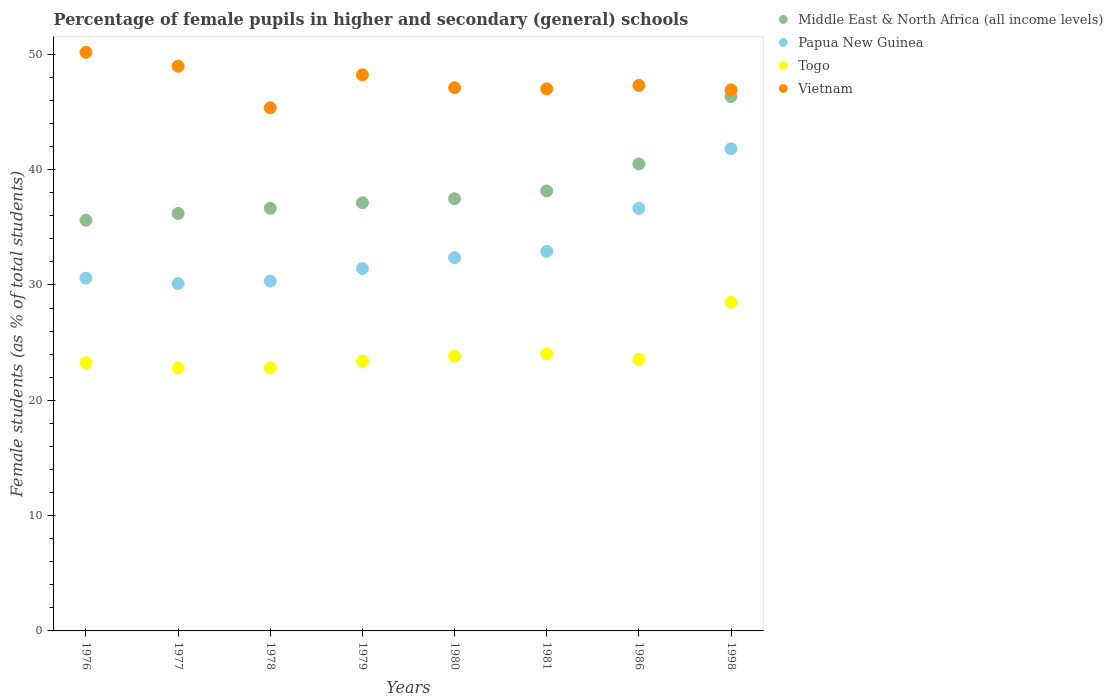How many different coloured dotlines are there?
Ensure brevity in your answer.  4. Is the number of dotlines equal to the number of legend labels?
Your answer should be compact. Yes. What is the percentage of female pupils in higher and secondary schools in Vietnam in 1977?
Offer a terse response. 48.97. Across all years, what is the maximum percentage of female pupils in higher and secondary schools in Vietnam?
Your answer should be compact. 50.17. Across all years, what is the minimum percentage of female pupils in higher and secondary schools in Togo?
Give a very brief answer. 22.81. In which year was the percentage of female pupils in higher and secondary schools in Togo maximum?
Ensure brevity in your answer.  1998. What is the total percentage of female pupils in higher and secondary schools in Papua New Guinea in the graph?
Make the answer very short. 266.19. What is the difference between the percentage of female pupils in higher and secondary schools in Vietnam in 1976 and that in 1980?
Keep it short and to the point. 3.07. What is the difference between the percentage of female pupils in higher and secondary schools in Papua New Guinea in 1998 and the percentage of female pupils in higher and secondary schools in Vietnam in 1986?
Your answer should be very brief. -5.49. What is the average percentage of female pupils in higher and secondary schools in Papua New Guinea per year?
Your response must be concise. 33.27. In the year 1998, what is the difference between the percentage of female pupils in higher and secondary schools in Vietnam and percentage of female pupils in higher and secondary schools in Middle East & North Africa (all income levels)?
Make the answer very short. 0.58. What is the ratio of the percentage of female pupils in higher and secondary schools in Papua New Guinea in 1980 to that in 1986?
Offer a very short reply. 0.88. Is the difference between the percentage of female pupils in higher and secondary schools in Vietnam in 1978 and 1981 greater than the difference between the percentage of female pupils in higher and secondary schools in Middle East & North Africa (all income levels) in 1978 and 1981?
Provide a succinct answer. No. What is the difference between the highest and the second highest percentage of female pupils in higher and secondary schools in Middle East & North Africa (all income levels)?
Provide a succinct answer. 5.84. What is the difference between the highest and the lowest percentage of female pupils in higher and secondary schools in Togo?
Keep it short and to the point. 5.7. Is the sum of the percentage of female pupils in higher and secondary schools in Papua New Guinea in 1976 and 1980 greater than the maximum percentage of female pupils in higher and secondary schools in Middle East & North Africa (all income levels) across all years?
Provide a succinct answer. Yes. Is it the case that in every year, the sum of the percentage of female pupils in higher and secondary schools in Middle East & North Africa (all income levels) and percentage of female pupils in higher and secondary schools in Togo  is greater than the sum of percentage of female pupils in higher and secondary schools in Papua New Guinea and percentage of female pupils in higher and secondary schools in Vietnam?
Your response must be concise. No. Is the percentage of female pupils in higher and secondary schools in Papua New Guinea strictly greater than the percentage of female pupils in higher and secondary schools in Togo over the years?
Your answer should be very brief. Yes. Are the values on the major ticks of Y-axis written in scientific E-notation?
Ensure brevity in your answer.  No. Does the graph contain any zero values?
Your answer should be compact. No. How many legend labels are there?
Provide a short and direct response. 4. How are the legend labels stacked?
Provide a succinct answer. Vertical. What is the title of the graph?
Offer a very short reply. Percentage of female pupils in higher and secondary (general) schools. What is the label or title of the X-axis?
Provide a succinct answer. Years. What is the label or title of the Y-axis?
Offer a very short reply. Female students (as % of total students). What is the Female students (as % of total students) in Middle East & North Africa (all income levels) in 1976?
Your answer should be very brief. 35.61. What is the Female students (as % of total students) in Papua New Guinea in 1976?
Your answer should be compact. 30.59. What is the Female students (as % of total students) in Togo in 1976?
Make the answer very short. 23.26. What is the Female students (as % of total students) of Vietnam in 1976?
Provide a short and direct response. 50.17. What is the Female students (as % of total students) of Middle East & North Africa (all income levels) in 1977?
Your answer should be very brief. 36.2. What is the Female students (as % of total students) of Papua New Guinea in 1977?
Provide a short and direct response. 30.11. What is the Female students (as % of total students) of Togo in 1977?
Keep it short and to the point. 22.81. What is the Female students (as % of total students) of Vietnam in 1977?
Offer a terse response. 48.97. What is the Female students (as % of total students) of Middle East & North Africa (all income levels) in 1978?
Offer a terse response. 36.65. What is the Female students (as % of total students) of Papua New Guinea in 1978?
Your response must be concise. 30.33. What is the Female students (as % of total students) in Togo in 1978?
Ensure brevity in your answer.  22.81. What is the Female students (as % of total students) of Vietnam in 1978?
Make the answer very short. 45.36. What is the Female students (as % of total students) in Middle East & North Africa (all income levels) in 1979?
Your response must be concise. 37.13. What is the Female students (as % of total students) of Papua New Guinea in 1979?
Ensure brevity in your answer.  31.42. What is the Female students (as % of total students) in Togo in 1979?
Ensure brevity in your answer.  23.4. What is the Female students (as % of total students) of Vietnam in 1979?
Provide a short and direct response. 48.22. What is the Female students (as % of total students) in Middle East & North Africa (all income levels) in 1980?
Ensure brevity in your answer.  37.48. What is the Female students (as % of total students) in Papua New Guinea in 1980?
Offer a very short reply. 32.37. What is the Female students (as % of total students) in Togo in 1980?
Offer a very short reply. 23.82. What is the Female students (as % of total students) of Vietnam in 1980?
Your response must be concise. 47.1. What is the Female students (as % of total students) of Middle East & North Africa (all income levels) in 1981?
Your answer should be very brief. 38.15. What is the Female students (as % of total students) in Papua New Guinea in 1981?
Offer a terse response. 32.91. What is the Female students (as % of total students) of Togo in 1981?
Your answer should be compact. 24.03. What is the Female students (as % of total students) in Vietnam in 1981?
Offer a very short reply. 47. What is the Female students (as % of total students) in Middle East & North Africa (all income levels) in 1986?
Ensure brevity in your answer.  40.49. What is the Female students (as % of total students) in Papua New Guinea in 1986?
Your answer should be very brief. 36.64. What is the Female students (as % of total students) of Togo in 1986?
Your response must be concise. 23.55. What is the Female students (as % of total students) of Vietnam in 1986?
Keep it short and to the point. 47.3. What is the Female students (as % of total students) of Middle East & North Africa (all income levels) in 1998?
Offer a terse response. 46.34. What is the Female students (as % of total students) of Papua New Guinea in 1998?
Make the answer very short. 41.81. What is the Female students (as % of total students) of Togo in 1998?
Offer a terse response. 28.51. What is the Female students (as % of total students) in Vietnam in 1998?
Your answer should be compact. 46.92. Across all years, what is the maximum Female students (as % of total students) in Middle East & North Africa (all income levels)?
Provide a succinct answer. 46.34. Across all years, what is the maximum Female students (as % of total students) of Papua New Guinea?
Your response must be concise. 41.81. Across all years, what is the maximum Female students (as % of total students) of Togo?
Make the answer very short. 28.51. Across all years, what is the maximum Female students (as % of total students) in Vietnam?
Offer a very short reply. 50.17. Across all years, what is the minimum Female students (as % of total students) of Middle East & North Africa (all income levels)?
Your response must be concise. 35.61. Across all years, what is the minimum Female students (as % of total students) in Papua New Guinea?
Keep it short and to the point. 30.11. Across all years, what is the minimum Female students (as % of total students) of Togo?
Your response must be concise. 22.81. Across all years, what is the minimum Female students (as % of total students) in Vietnam?
Your answer should be compact. 45.36. What is the total Female students (as % of total students) of Middle East & North Africa (all income levels) in the graph?
Ensure brevity in your answer.  308.04. What is the total Female students (as % of total students) in Papua New Guinea in the graph?
Your response must be concise. 266.19. What is the total Female students (as % of total students) in Togo in the graph?
Keep it short and to the point. 192.18. What is the total Female students (as % of total students) in Vietnam in the graph?
Make the answer very short. 381.05. What is the difference between the Female students (as % of total students) in Middle East & North Africa (all income levels) in 1976 and that in 1977?
Ensure brevity in your answer.  -0.59. What is the difference between the Female students (as % of total students) in Papua New Guinea in 1976 and that in 1977?
Keep it short and to the point. 0.47. What is the difference between the Female students (as % of total students) of Togo in 1976 and that in 1977?
Keep it short and to the point. 0.45. What is the difference between the Female students (as % of total students) of Vietnam in 1976 and that in 1977?
Make the answer very short. 1.2. What is the difference between the Female students (as % of total students) in Middle East & North Africa (all income levels) in 1976 and that in 1978?
Offer a terse response. -1.03. What is the difference between the Female students (as % of total students) of Papua New Guinea in 1976 and that in 1978?
Provide a succinct answer. 0.25. What is the difference between the Female students (as % of total students) of Togo in 1976 and that in 1978?
Provide a succinct answer. 0.45. What is the difference between the Female students (as % of total students) of Vietnam in 1976 and that in 1978?
Offer a terse response. 4.81. What is the difference between the Female students (as % of total students) in Middle East & North Africa (all income levels) in 1976 and that in 1979?
Make the answer very short. -1.52. What is the difference between the Female students (as % of total students) of Papua New Guinea in 1976 and that in 1979?
Make the answer very short. -0.84. What is the difference between the Female students (as % of total students) in Togo in 1976 and that in 1979?
Your answer should be very brief. -0.14. What is the difference between the Female students (as % of total students) in Vietnam in 1976 and that in 1979?
Your answer should be very brief. 1.95. What is the difference between the Female students (as % of total students) of Middle East & North Africa (all income levels) in 1976 and that in 1980?
Provide a succinct answer. -1.87. What is the difference between the Female students (as % of total students) of Papua New Guinea in 1976 and that in 1980?
Ensure brevity in your answer.  -1.78. What is the difference between the Female students (as % of total students) of Togo in 1976 and that in 1980?
Provide a short and direct response. -0.56. What is the difference between the Female students (as % of total students) in Vietnam in 1976 and that in 1980?
Provide a succinct answer. 3.07. What is the difference between the Female students (as % of total students) of Middle East & North Africa (all income levels) in 1976 and that in 1981?
Give a very brief answer. -2.54. What is the difference between the Female students (as % of total students) of Papua New Guinea in 1976 and that in 1981?
Your answer should be very brief. -2.32. What is the difference between the Female students (as % of total students) of Togo in 1976 and that in 1981?
Provide a succinct answer. -0.77. What is the difference between the Female students (as % of total students) of Vietnam in 1976 and that in 1981?
Your answer should be compact. 3.17. What is the difference between the Female students (as % of total students) of Middle East & North Africa (all income levels) in 1976 and that in 1986?
Offer a very short reply. -4.88. What is the difference between the Female students (as % of total students) in Papua New Guinea in 1976 and that in 1986?
Your response must be concise. -6.06. What is the difference between the Female students (as % of total students) of Togo in 1976 and that in 1986?
Make the answer very short. -0.29. What is the difference between the Female students (as % of total students) in Vietnam in 1976 and that in 1986?
Your answer should be very brief. 2.87. What is the difference between the Female students (as % of total students) in Middle East & North Africa (all income levels) in 1976 and that in 1998?
Your answer should be compact. -10.73. What is the difference between the Female students (as % of total students) of Papua New Guinea in 1976 and that in 1998?
Offer a very short reply. -11.23. What is the difference between the Female students (as % of total students) in Togo in 1976 and that in 1998?
Give a very brief answer. -5.25. What is the difference between the Female students (as % of total students) in Middle East & North Africa (all income levels) in 1977 and that in 1978?
Keep it short and to the point. -0.45. What is the difference between the Female students (as % of total students) of Papua New Guinea in 1977 and that in 1978?
Your answer should be compact. -0.22. What is the difference between the Female students (as % of total students) in Togo in 1977 and that in 1978?
Offer a very short reply. -0. What is the difference between the Female students (as % of total students) of Vietnam in 1977 and that in 1978?
Keep it short and to the point. 3.6. What is the difference between the Female students (as % of total students) in Middle East & North Africa (all income levels) in 1977 and that in 1979?
Provide a short and direct response. -0.93. What is the difference between the Female students (as % of total students) in Papua New Guinea in 1977 and that in 1979?
Keep it short and to the point. -1.31. What is the difference between the Female students (as % of total students) of Togo in 1977 and that in 1979?
Provide a succinct answer. -0.59. What is the difference between the Female students (as % of total students) of Vietnam in 1977 and that in 1979?
Your response must be concise. 0.75. What is the difference between the Female students (as % of total students) of Middle East & North Africa (all income levels) in 1977 and that in 1980?
Your answer should be compact. -1.28. What is the difference between the Female students (as % of total students) of Papua New Guinea in 1977 and that in 1980?
Offer a very short reply. -2.25. What is the difference between the Female students (as % of total students) in Togo in 1977 and that in 1980?
Provide a succinct answer. -1.01. What is the difference between the Female students (as % of total students) in Vietnam in 1977 and that in 1980?
Ensure brevity in your answer.  1.86. What is the difference between the Female students (as % of total students) in Middle East & North Africa (all income levels) in 1977 and that in 1981?
Make the answer very short. -1.96. What is the difference between the Female students (as % of total students) in Papua New Guinea in 1977 and that in 1981?
Give a very brief answer. -2.79. What is the difference between the Female students (as % of total students) of Togo in 1977 and that in 1981?
Make the answer very short. -1.22. What is the difference between the Female students (as % of total students) in Vietnam in 1977 and that in 1981?
Make the answer very short. 1.97. What is the difference between the Female students (as % of total students) in Middle East & North Africa (all income levels) in 1977 and that in 1986?
Keep it short and to the point. -4.3. What is the difference between the Female students (as % of total students) of Papua New Guinea in 1977 and that in 1986?
Make the answer very short. -6.53. What is the difference between the Female students (as % of total students) in Togo in 1977 and that in 1986?
Ensure brevity in your answer.  -0.74. What is the difference between the Female students (as % of total students) in Vietnam in 1977 and that in 1986?
Your response must be concise. 1.66. What is the difference between the Female students (as % of total students) in Middle East & North Africa (all income levels) in 1977 and that in 1998?
Your answer should be compact. -10.14. What is the difference between the Female students (as % of total students) of Papua New Guinea in 1977 and that in 1998?
Provide a short and direct response. -11.7. What is the difference between the Female students (as % of total students) of Togo in 1977 and that in 1998?
Give a very brief answer. -5.7. What is the difference between the Female students (as % of total students) in Vietnam in 1977 and that in 1998?
Provide a succinct answer. 2.05. What is the difference between the Female students (as % of total students) in Middle East & North Africa (all income levels) in 1978 and that in 1979?
Make the answer very short. -0.48. What is the difference between the Female students (as % of total students) in Papua New Guinea in 1978 and that in 1979?
Give a very brief answer. -1.09. What is the difference between the Female students (as % of total students) of Togo in 1978 and that in 1979?
Provide a succinct answer. -0.59. What is the difference between the Female students (as % of total students) in Vietnam in 1978 and that in 1979?
Your answer should be compact. -2.86. What is the difference between the Female students (as % of total students) of Middle East & North Africa (all income levels) in 1978 and that in 1980?
Provide a succinct answer. -0.83. What is the difference between the Female students (as % of total students) in Papua New Guinea in 1978 and that in 1980?
Your answer should be very brief. -2.03. What is the difference between the Female students (as % of total students) of Togo in 1978 and that in 1980?
Your answer should be compact. -1.01. What is the difference between the Female students (as % of total students) in Vietnam in 1978 and that in 1980?
Provide a succinct answer. -1.74. What is the difference between the Female students (as % of total students) of Middle East & North Africa (all income levels) in 1978 and that in 1981?
Offer a terse response. -1.51. What is the difference between the Female students (as % of total students) in Papua New Guinea in 1978 and that in 1981?
Give a very brief answer. -2.57. What is the difference between the Female students (as % of total students) in Togo in 1978 and that in 1981?
Your response must be concise. -1.22. What is the difference between the Female students (as % of total students) of Vietnam in 1978 and that in 1981?
Keep it short and to the point. -1.64. What is the difference between the Female students (as % of total students) of Middle East & North Africa (all income levels) in 1978 and that in 1986?
Ensure brevity in your answer.  -3.85. What is the difference between the Female students (as % of total students) of Papua New Guinea in 1978 and that in 1986?
Your answer should be very brief. -6.31. What is the difference between the Female students (as % of total students) in Togo in 1978 and that in 1986?
Offer a very short reply. -0.73. What is the difference between the Female students (as % of total students) in Vietnam in 1978 and that in 1986?
Offer a terse response. -1.94. What is the difference between the Female students (as % of total students) in Middle East & North Africa (all income levels) in 1978 and that in 1998?
Offer a very short reply. -9.69. What is the difference between the Female students (as % of total students) in Papua New Guinea in 1978 and that in 1998?
Provide a succinct answer. -11.48. What is the difference between the Female students (as % of total students) of Togo in 1978 and that in 1998?
Keep it short and to the point. -5.69. What is the difference between the Female students (as % of total students) in Vietnam in 1978 and that in 1998?
Offer a terse response. -1.56. What is the difference between the Female students (as % of total students) of Middle East & North Africa (all income levels) in 1979 and that in 1980?
Make the answer very short. -0.35. What is the difference between the Female students (as % of total students) of Papua New Guinea in 1979 and that in 1980?
Your response must be concise. -0.95. What is the difference between the Female students (as % of total students) in Togo in 1979 and that in 1980?
Ensure brevity in your answer.  -0.42. What is the difference between the Female students (as % of total students) in Vietnam in 1979 and that in 1980?
Provide a short and direct response. 1.12. What is the difference between the Female students (as % of total students) in Middle East & North Africa (all income levels) in 1979 and that in 1981?
Your answer should be very brief. -1.02. What is the difference between the Female students (as % of total students) of Papua New Guinea in 1979 and that in 1981?
Offer a terse response. -1.49. What is the difference between the Female students (as % of total students) of Togo in 1979 and that in 1981?
Keep it short and to the point. -0.63. What is the difference between the Female students (as % of total students) in Vietnam in 1979 and that in 1981?
Keep it short and to the point. 1.22. What is the difference between the Female students (as % of total students) in Middle East & North Africa (all income levels) in 1979 and that in 1986?
Ensure brevity in your answer.  -3.37. What is the difference between the Female students (as % of total students) in Papua New Guinea in 1979 and that in 1986?
Offer a very short reply. -5.22. What is the difference between the Female students (as % of total students) in Togo in 1979 and that in 1986?
Make the answer very short. -0.14. What is the difference between the Female students (as % of total students) in Vietnam in 1979 and that in 1986?
Offer a very short reply. 0.92. What is the difference between the Female students (as % of total students) of Middle East & North Africa (all income levels) in 1979 and that in 1998?
Make the answer very short. -9.21. What is the difference between the Female students (as % of total students) of Papua New Guinea in 1979 and that in 1998?
Your answer should be compact. -10.39. What is the difference between the Female students (as % of total students) of Togo in 1979 and that in 1998?
Offer a very short reply. -5.11. What is the difference between the Female students (as % of total students) in Vietnam in 1979 and that in 1998?
Your response must be concise. 1.3. What is the difference between the Female students (as % of total students) in Middle East & North Africa (all income levels) in 1980 and that in 1981?
Keep it short and to the point. -0.68. What is the difference between the Female students (as % of total students) of Papua New Guinea in 1980 and that in 1981?
Your response must be concise. -0.54. What is the difference between the Female students (as % of total students) of Togo in 1980 and that in 1981?
Your response must be concise. -0.21. What is the difference between the Female students (as % of total students) in Vietnam in 1980 and that in 1981?
Make the answer very short. 0.1. What is the difference between the Female students (as % of total students) of Middle East & North Africa (all income levels) in 1980 and that in 1986?
Keep it short and to the point. -3.02. What is the difference between the Female students (as % of total students) in Papua New Guinea in 1980 and that in 1986?
Give a very brief answer. -4.28. What is the difference between the Female students (as % of total students) in Togo in 1980 and that in 1986?
Make the answer very short. 0.27. What is the difference between the Female students (as % of total students) of Vietnam in 1980 and that in 1986?
Provide a succinct answer. -0.2. What is the difference between the Female students (as % of total students) in Middle East & North Africa (all income levels) in 1980 and that in 1998?
Provide a succinct answer. -8.86. What is the difference between the Female students (as % of total students) in Papua New Guinea in 1980 and that in 1998?
Offer a very short reply. -9.45. What is the difference between the Female students (as % of total students) in Togo in 1980 and that in 1998?
Your answer should be compact. -4.69. What is the difference between the Female students (as % of total students) of Vietnam in 1980 and that in 1998?
Provide a short and direct response. 0.18. What is the difference between the Female students (as % of total students) of Middle East & North Africa (all income levels) in 1981 and that in 1986?
Give a very brief answer. -2.34. What is the difference between the Female students (as % of total students) in Papua New Guinea in 1981 and that in 1986?
Provide a succinct answer. -3.73. What is the difference between the Female students (as % of total students) in Togo in 1981 and that in 1986?
Offer a terse response. 0.48. What is the difference between the Female students (as % of total students) of Vietnam in 1981 and that in 1986?
Provide a succinct answer. -0.3. What is the difference between the Female students (as % of total students) of Middle East & North Africa (all income levels) in 1981 and that in 1998?
Keep it short and to the point. -8.18. What is the difference between the Female students (as % of total students) of Papua New Guinea in 1981 and that in 1998?
Offer a very short reply. -8.91. What is the difference between the Female students (as % of total students) in Togo in 1981 and that in 1998?
Provide a succinct answer. -4.48. What is the difference between the Female students (as % of total students) in Vietnam in 1981 and that in 1998?
Give a very brief answer. 0.08. What is the difference between the Female students (as % of total students) of Middle East & North Africa (all income levels) in 1986 and that in 1998?
Your answer should be compact. -5.84. What is the difference between the Female students (as % of total students) in Papua New Guinea in 1986 and that in 1998?
Offer a terse response. -5.17. What is the difference between the Female students (as % of total students) in Togo in 1986 and that in 1998?
Your response must be concise. -4.96. What is the difference between the Female students (as % of total students) of Vietnam in 1986 and that in 1998?
Provide a short and direct response. 0.38. What is the difference between the Female students (as % of total students) in Middle East & North Africa (all income levels) in 1976 and the Female students (as % of total students) in Papua New Guinea in 1977?
Keep it short and to the point. 5.5. What is the difference between the Female students (as % of total students) in Middle East & North Africa (all income levels) in 1976 and the Female students (as % of total students) in Togo in 1977?
Your answer should be compact. 12.8. What is the difference between the Female students (as % of total students) of Middle East & North Africa (all income levels) in 1976 and the Female students (as % of total students) of Vietnam in 1977?
Your answer should be compact. -13.36. What is the difference between the Female students (as % of total students) of Papua New Guinea in 1976 and the Female students (as % of total students) of Togo in 1977?
Keep it short and to the point. 7.78. What is the difference between the Female students (as % of total students) in Papua New Guinea in 1976 and the Female students (as % of total students) in Vietnam in 1977?
Offer a terse response. -18.38. What is the difference between the Female students (as % of total students) in Togo in 1976 and the Female students (as % of total students) in Vietnam in 1977?
Provide a succinct answer. -25.71. What is the difference between the Female students (as % of total students) of Middle East & North Africa (all income levels) in 1976 and the Female students (as % of total students) of Papua New Guinea in 1978?
Your answer should be compact. 5.28. What is the difference between the Female students (as % of total students) of Middle East & North Africa (all income levels) in 1976 and the Female students (as % of total students) of Togo in 1978?
Ensure brevity in your answer.  12.8. What is the difference between the Female students (as % of total students) of Middle East & North Africa (all income levels) in 1976 and the Female students (as % of total students) of Vietnam in 1978?
Provide a short and direct response. -9.75. What is the difference between the Female students (as % of total students) of Papua New Guinea in 1976 and the Female students (as % of total students) of Togo in 1978?
Your response must be concise. 7.77. What is the difference between the Female students (as % of total students) of Papua New Guinea in 1976 and the Female students (as % of total students) of Vietnam in 1978?
Your answer should be compact. -14.78. What is the difference between the Female students (as % of total students) of Togo in 1976 and the Female students (as % of total students) of Vietnam in 1978?
Keep it short and to the point. -22.11. What is the difference between the Female students (as % of total students) in Middle East & North Africa (all income levels) in 1976 and the Female students (as % of total students) in Papua New Guinea in 1979?
Give a very brief answer. 4.19. What is the difference between the Female students (as % of total students) in Middle East & North Africa (all income levels) in 1976 and the Female students (as % of total students) in Togo in 1979?
Offer a terse response. 12.21. What is the difference between the Female students (as % of total students) of Middle East & North Africa (all income levels) in 1976 and the Female students (as % of total students) of Vietnam in 1979?
Provide a succinct answer. -12.61. What is the difference between the Female students (as % of total students) of Papua New Guinea in 1976 and the Female students (as % of total students) of Togo in 1979?
Your response must be concise. 7.19. What is the difference between the Female students (as % of total students) in Papua New Guinea in 1976 and the Female students (as % of total students) in Vietnam in 1979?
Offer a terse response. -17.64. What is the difference between the Female students (as % of total students) in Togo in 1976 and the Female students (as % of total students) in Vietnam in 1979?
Keep it short and to the point. -24.96. What is the difference between the Female students (as % of total students) in Middle East & North Africa (all income levels) in 1976 and the Female students (as % of total students) in Papua New Guinea in 1980?
Offer a terse response. 3.24. What is the difference between the Female students (as % of total students) of Middle East & North Africa (all income levels) in 1976 and the Female students (as % of total students) of Togo in 1980?
Ensure brevity in your answer.  11.79. What is the difference between the Female students (as % of total students) of Middle East & North Africa (all income levels) in 1976 and the Female students (as % of total students) of Vietnam in 1980?
Keep it short and to the point. -11.49. What is the difference between the Female students (as % of total students) of Papua New Guinea in 1976 and the Female students (as % of total students) of Togo in 1980?
Your response must be concise. 6.77. What is the difference between the Female students (as % of total students) of Papua New Guinea in 1976 and the Female students (as % of total students) of Vietnam in 1980?
Ensure brevity in your answer.  -16.52. What is the difference between the Female students (as % of total students) of Togo in 1976 and the Female students (as % of total students) of Vietnam in 1980?
Provide a succinct answer. -23.84. What is the difference between the Female students (as % of total students) of Middle East & North Africa (all income levels) in 1976 and the Female students (as % of total students) of Papua New Guinea in 1981?
Offer a terse response. 2.7. What is the difference between the Female students (as % of total students) of Middle East & North Africa (all income levels) in 1976 and the Female students (as % of total students) of Togo in 1981?
Keep it short and to the point. 11.58. What is the difference between the Female students (as % of total students) of Middle East & North Africa (all income levels) in 1976 and the Female students (as % of total students) of Vietnam in 1981?
Provide a succinct answer. -11.39. What is the difference between the Female students (as % of total students) of Papua New Guinea in 1976 and the Female students (as % of total students) of Togo in 1981?
Provide a short and direct response. 6.56. What is the difference between the Female students (as % of total students) in Papua New Guinea in 1976 and the Female students (as % of total students) in Vietnam in 1981?
Your answer should be very brief. -16.42. What is the difference between the Female students (as % of total students) of Togo in 1976 and the Female students (as % of total students) of Vietnam in 1981?
Offer a terse response. -23.74. What is the difference between the Female students (as % of total students) of Middle East & North Africa (all income levels) in 1976 and the Female students (as % of total students) of Papua New Guinea in 1986?
Provide a succinct answer. -1.03. What is the difference between the Female students (as % of total students) of Middle East & North Africa (all income levels) in 1976 and the Female students (as % of total students) of Togo in 1986?
Your answer should be compact. 12.06. What is the difference between the Female students (as % of total students) in Middle East & North Africa (all income levels) in 1976 and the Female students (as % of total students) in Vietnam in 1986?
Make the answer very short. -11.69. What is the difference between the Female students (as % of total students) in Papua New Guinea in 1976 and the Female students (as % of total students) in Togo in 1986?
Make the answer very short. 7.04. What is the difference between the Female students (as % of total students) in Papua New Guinea in 1976 and the Female students (as % of total students) in Vietnam in 1986?
Your response must be concise. -16.72. What is the difference between the Female students (as % of total students) in Togo in 1976 and the Female students (as % of total students) in Vietnam in 1986?
Keep it short and to the point. -24.04. What is the difference between the Female students (as % of total students) in Middle East & North Africa (all income levels) in 1976 and the Female students (as % of total students) in Papua New Guinea in 1998?
Your response must be concise. -6.2. What is the difference between the Female students (as % of total students) in Middle East & North Africa (all income levels) in 1976 and the Female students (as % of total students) in Togo in 1998?
Your response must be concise. 7.1. What is the difference between the Female students (as % of total students) in Middle East & North Africa (all income levels) in 1976 and the Female students (as % of total students) in Vietnam in 1998?
Provide a succinct answer. -11.31. What is the difference between the Female students (as % of total students) of Papua New Guinea in 1976 and the Female students (as % of total students) of Togo in 1998?
Provide a succinct answer. 2.08. What is the difference between the Female students (as % of total students) in Papua New Guinea in 1976 and the Female students (as % of total students) in Vietnam in 1998?
Offer a terse response. -16.33. What is the difference between the Female students (as % of total students) in Togo in 1976 and the Female students (as % of total students) in Vietnam in 1998?
Keep it short and to the point. -23.66. What is the difference between the Female students (as % of total students) in Middle East & North Africa (all income levels) in 1977 and the Female students (as % of total students) in Papua New Guinea in 1978?
Your answer should be compact. 5.86. What is the difference between the Female students (as % of total students) in Middle East & North Africa (all income levels) in 1977 and the Female students (as % of total students) in Togo in 1978?
Provide a succinct answer. 13.38. What is the difference between the Female students (as % of total students) of Middle East & North Africa (all income levels) in 1977 and the Female students (as % of total students) of Vietnam in 1978?
Provide a succinct answer. -9.17. What is the difference between the Female students (as % of total students) of Papua New Guinea in 1977 and the Female students (as % of total students) of Togo in 1978?
Ensure brevity in your answer.  7.3. What is the difference between the Female students (as % of total students) of Papua New Guinea in 1977 and the Female students (as % of total students) of Vietnam in 1978?
Provide a succinct answer. -15.25. What is the difference between the Female students (as % of total students) of Togo in 1977 and the Female students (as % of total students) of Vietnam in 1978?
Your response must be concise. -22.55. What is the difference between the Female students (as % of total students) in Middle East & North Africa (all income levels) in 1977 and the Female students (as % of total students) in Papua New Guinea in 1979?
Keep it short and to the point. 4.77. What is the difference between the Female students (as % of total students) of Middle East & North Africa (all income levels) in 1977 and the Female students (as % of total students) of Togo in 1979?
Offer a terse response. 12.8. What is the difference between the Female students (as % of total students) in Middle East & North Africa (all income levels) in 1977 and the Female students (as % of total students) in Vietnam in 1979?
Make the answer very short. -12.03. What is the difference between the Female students (as % of total students) of Papua New Guinea in 1977 and the Female students (as % of total students) of Togo in 1979?
Your answer should be compact. 6.71. What is the difference between the Female students (as % of total students) in Papua New Guinea in 1977 and the Female students (as % of total students) in Vietnam in 1979?
Your answer should be compact. -18.11. What is the difference between the Female students (as % of total students) of Togo in 1977 and the Female students (as % of total students) of Vietnam in 1979?
Provide a succinct answer. -25.41. What is the difference between the Female students (as % of total students) of Middle East & North Africa (all income levels) in 1977 and the Female students (as % of total students) of Papua New Guinea in 1980?
Your answer should be very brief. 3.83. What is the difference between the Female students (as % of total students) of Middle East & North Africa (all income levels) in 1977 and the Female students (as % of total students) of Togo in 1980?
Your answer should be compact. 12.38. What is the difference between the Female students (as % of total students) in Middle East & North Africa (all income levels) in 1977 and the Female students (as % of total students) in Vietnam in 1980?
Make the answer very short. -10.91. What is the difference between the Female students (as % of total students) of Papua New Guinea in 1977 and the Female students (as % of total students) of Togo in 1980?
Make the answer very short. 6.3. What is the difference between the Female students (as % of total students) in Papua New Guinea in 1977 and the Female students (as % of total students) in Vietnam in 1980?
Provide a short and direct response. -16.99. What is the difference between the Female students (as % of total students) in Togo in 1977 and the Female students (as % of total students) in Vietnam in 1980?
Provide a succinct answer. -24.29. What is the difference between the Female students (as % of total students) in Middle East & North Africa (all income levels) in 1977 and the Female students (as % of total students) in Papua New Guinea in 1981?
Make the answer very short. 3.29. What is the difference between the Female students (as % of total students) of Middle East & North Africa (all income levels) in 1977 and the Female students (as % of total students) of Togo in 1981?
Make the answer very short. 12.17. What is the difference between the Female students (as % of total students) in Middle East & North Africa (all income levels) in 1977 and the Female students (as % of total students) in Vietnam in 1981?
Provide a succinct answer. -10.8. What is the difference between the Female students (as % of total students) of Papua New Guinea in 1977 and the Female students (as % of total students) of Togo in 1981?
Provide a succinct answer. 6.09. What is the difference between the Female students (as % of total students) in Papua New Guinea in 1977 and the Female students (as % of total students) in Vietnam in 1981?
Provide a short and direct response. -16.89. What is the difference between the Female students (as % of total students) of Togo in 1977 and the Female students (as % of total students) of Vietnam in 1981?
Provide a succinct answer. -24.19. What is the difference between the Female students (as % of total students) in Middle East & North Africa (all income levels) in 1977 and the Female students (as % of total students) in Papua New Guinea in 1986?
Offer a terse response. -0.45. What is the difference between the Female students (as % of total students) in Middle East & North Africa (all income levels) in 1977 and the Female students (as % of total students) in Togo in 1986?
Your response must be concise. 12.65. What is the difference between the Female students (as % of total students) in Middle East & North Africa (all income levels) in 1977 and the Female students (as % of total students) in Vietnam in 1986?
Provide a succinct answer. -11.11. What is the difference between the Female students (as % of total students) in Papua New Guinea in 1977 and the Female students (as % of total students) in Togo in 1986?
Keep it short and to the point. 6.57. What is the difference between the Female students (as % of total students) of Papua New Guinea in 1977 and the Female students (as % of total students) of Vietnam in 1986?
Provide a short and direct response. -17.19. What is the difference between the Female students (as % of total students) in Togo in 1977 and the Female students (as % of total students) in Vietnam in 1986?
Provide a succinct answer. -24.49. What is the difference between the Female students (as % of total students) of Middle East & North Africa (all income levels) in 1977 and the Female students (as % of total students) of Papua New Guinea in 1998?
Ensure brevity in your answer.  -5.62. What is the difference between the Female students (as % of total students) of Middle East & North Africa (all income levels) in 1977 and the Female students (as % of total students) of Togo in 1998?
Ensure brevity in your answer.  7.69. What is the difference between the Female students (as % of total students) in Middle East & North Africa (all income levels) in 1977 and the Female students (as % of total students) in Vietnam in 1998?
Offer a very short reply. -10.72. What is the difference between the Female students (as % of total students) of Papua New Guinea in 1977 and the Female students (as % of total students) of Togo in 1998?
Your answer should be compact. 1.61. What is the difference between the Female students (as % of total students) in Papua New Guinea in 1977 and the Female students (as % of total students) in Vietnam in 1998?
Provide a succinct answer. -16.81. What is the difference between the Female students (as % of total students) in Togo in 1977 and the Female students (as % of total students) in Vietnam in 1998?
Make the answer very short. -24.11. What is the difference between the Female students (as % of total students) in Middle East & North Africa (all income levels) in 1978 and the Female students (as % of total students) in Papua New Guinea in 1979?
Offer a very short reply. 5.22. What is the difference between the Female students (as % of total students) of Middle East & North Africa (all income levels) in 1978 and the Female students (as % of total students) of Togo in 1979?
Make the answer very short. 13.24. What is the difference between the Female students (as % of total students) of Middle East & North Africa (all income levels) in 1978 and the Female students (as % of total students) of Vietnam in 1979?
Your answer should be compact. -11.58. What is the difference between the Female students (as % of total students) of Papua New Guinea in 1978 and the Female students (as % of total students) of Togo in 1979?
Your response must be concise. 6.93. What is the difference between the Female students (as % of total students) in Papua New Guinea in 1978 and the Female students (as % of total students) in Vietnam in 1979?
Your response must be concise. -17.89. What is the difference between the Female students (as % of total students) of Togo in 1978 and the Female students (as % of total students) of Vietnam in 1979?
Provide a short and direct response. -25.41. What is the difference between the Female students (as % of total students) of Middle East & North Africa (all income levels) in 1978 and the Female students (as % of total students) of Papua New Guinea in 1980?
Make the answer very short. 4.28. What is the difference between the Female students (as % of total students) in Middle East & North Africa (all income levels) in 1978 and the Female students (as % of total students) in Togo in 1980?
Offer a very short reply. 12.83. What is the difference between the Female students (as % of total students) of Middle East & North Africa (all income levels) in 1978 and the Female students (as % of total students) of Vietnam in 1980?
Give a very brief answer. -10.46. What is the difference between the Female students (as % of total students) in Papua New Guinea in 1978 and the Female students (as % of total students) in Togo in 1980?
Offer a very short reply. 6.52. What is the difference between the Female students (as % of total students) of Papua New Guinea in 1978 and the Female students (as % of total students) of Vietnam in 1980?
Offer a very short reply. -16.77. What is the difference between the Female students (as % of total students) of Togo in 1978 and the Female students (as % of total students) of Vietnam in 1980?
Keep it short and to the point. -24.29. What is the difference between the Female students (as % of total students) of Middle East & North Africa (all income levels) in 1978 and the Female students (as % of total students) of Papua New Guinea in 1981?
Ensure brevity in your answer.  3.74. What is the difference between the Female students (as % of total students) of Middle East & North Africa (all income levels) in 1978 and the Female students (as % of total students) of Togo in 1981?
Your answer should be compact. 12.62. What is the difference between the Female students (as % of total students) in Middle East & North Africa (all income levels) in 1978 and the Female students (as % of total students) in Vietnam in 1981?
Ensure brevity in your answer.  -10.36. What is the difference between the Female students (as % of total students) in Papua New Guinea in 1978 and the Female students (as % of total students) in Togo in 1981?
Offer a very short reply. 6.3. What is the difference between the Female students (as % of total students) in Papua New Guinea in 1978 and the Female students (as % of total students) in Vietnam in 1981?
Keep it short and to the point. -16.67. What is the difference between the Female students (as % of total students) of Togo in 1978 and the Female students (as % of total students) of Vietnam in 1981?
Offer a very short reply. -24.19. What is the difference between the Female students (as % of total students) in Middle East & North Africa (all income levels) in 1978 and the Female students (as % of total students) in Papua New Guinea in 1986?
Provide a short and direct response. 0. What is the difference between the Female students (as % of total students) in Middle East & North Africa (all income levels) in 1978 and the Female students (as % of total students) in Togo in 1986?
Offer a very short reply. 13.1. What is the difference between the Female students (as % of total students) in Middle East & North Africa (all income levels) in 1978 and the Female students (as % of total students) in Vietnam in 1986?
Give a very brief answer. -10.66. What is the difference between the Female students (as % of total students) in Papua New Guinea in 1978 and the Female students (as % of total students) in Togo in 1986?
Your answer should be compact. 6.79. What is the difference between the Female students (as % of total students) of Papua New Guinea in 1978 and the Female students (as % of total students) of Vietnam in 1986?
Make the answer very short. -16.97. What is the difference between the Female students (as % of total students) of Togo in 1978 and the Female students (as % of total students) of Vietnam in 1986?
Give a very brief answer. -24.49. What is the difference between the Female students (as % of total students) in Middle East & North Africa (all income levels) in 1978 and the Female students (as % of total students) in Papua New Guinea in 1998?
Provide a succinct answer. -5.17. What is the difference between the Female students (as % of total students) of Middle East & North Africa (all income levels) in 1978 and the Female students (as % of total students) of Togo in 1998?
Make the answer very short. 8.14. What is the difference between the Female students (as % of total students) of Middle East & North Africa (all income levels) in 1978 and the Female students (as % of total students) of Vietnam in 1998?
Your answer should be very brief. -10.27. What is the difference between the Female students (as % of total students) of Papua New Guinea in 1978 and the Female students (as % of total students) of Togo in 1998?
Make the answer very short. 1.83. What is the difference between the Female students (as % of total students) of Papua New Guinea in 1978 and the Female students (as % of total students) of Vietnam in 1998?
Ensure brevity in your answer.  -16.59. What is the difference between the Female students (as % of total students) in Togo in 1978 and the Female students (as % of total students) in Vietnam in 1998?
Keep it short and to the point. -24.11. What is the difference between the Female students (as % of total students) in Middle East & North Africa (all income levels) in 1979 and the Female students (as % of total students) in Papua New Guinea in 1980?
Provide a succinct answer. 4.76. What is the difference between the Female students (as % of total students) in Middle East & North Africa (all income levels) in 1979 and the Female students (as % of total students) in Togo in 1980?
Keep it short and to the point. 13.31. What is the difference between the Female students (as % of total students) in Middle East & North Africa (all income levels) in 1979 and the Female students (as % of total students) in Vietnam in 1980?
Provide a short and direct response. -9.97. What is the difference between the Female students (as % of total students) of Papua New Guinea in 1979 and the Female students (as % of total students) of Togo in 1980?
Your answer should be very brief. 7.6. What is the difference between the Female students (as % of total students) in Papua New Guinea in 1979 and the Female students (as % of total students) in Vietnam in 1980?
Keep it short and to the point. -15.68. What is the difference between the Female students (as % of total students) in Togo in 1979 and the Female students (as % of total students) in Vietnam in 1980?
Offer a terse response. -23.7. What is the difference between the Female students (as % of total students) of Middle East & North Africa (all income levels) in 1979 and the Female students (as % of total students) of Papua New Guinea in 1981?
Offer a terse response. 4.22. What is the difference between the Female students (as % of total students) in Middle East & North Africa (all income levels) in 1979 and the Female students (as % of total students) in Togo in 1981?
Offer a very short reply. 13.1. What is the difference between the Female students (as % of total students) of Middle East & North Africa (all income levels) in 1979 and the Female students (as % of total students) of Vietnam in 1981?
Offer a terse response. -9.87. What is the difference between the Female students (as % of total students) in Papua New Guinea in 1979 and the Female students (as % of total students) in Togo in 1981?
Your answer should be very brief. 7.39. What is the difference between the Female students (as % of total students) in Papua New Guinea in 1979 and the Female students (as % of total students) in Vietnam in 1981?
Provide a succinct answer. -15.58. What is the difference between the Female students (as % of total students) of Togo in 1979 and the Female students (as % of total students) of Vietnam in 1981?
Provide a short and direct response. -23.6. What is the difference between the Female students (as % of total students) in Middle East & North Africa (all income levels) in 1979 and the Female students (as % of total students) in Papua New Guinea in 1986?
Your answer should be compact. 0.49. What is the difference between the Female students (as % of total students) of Middle East & North Africa (all income levels) in 1979 and the Female students (as % of total students) of Togo in 1986?
Provide a succinct answer. 13.58. What is the difference between the Female students (as % of total students) of Middle East & North Africa (all income levels) in 1979 and the Female students (as % of total students) of Vietnam in 1986?
Offer a terse response. -10.17. What is the difference between the Female students (as % of total students) of Papua New Guinea in 1979 and the Female students (as % of total students) of Togo in 1986?
Provide a succinct answer. 7.88. What is the difference between the Female students (as % of total students) of Papua New Guinea in 1979 and the Female students (as % of total students) of Vietnam in 1986?
Make the answer very short. -15.88. What is the difference between the Female students (as % of total students) in Togo in 1979 and the Female students (as % of total students) in Vietnam in 1986?
Offer a terse response. -23.9. What is the difference between the Female students (as % of total students) of Middle East & North Africa (all income levels) in 1979 and the Female students (as % of total students) of Papua New Guinea in 1998?
Provide a succinct answer. -4.68. What is the difference between the Female students (as % of total students) in Middle East & North Africa (all income levels) in 1979 and the Female students (as % of total students) in Togo in 1998?
Offer a very short reply. 8.62. What is the difference between the Female students (as % of total students) of Middle East & North Africa (all income levels) in 1979 and the Female students (as % of total students) of Vietnam in 1998?
Provide a short and direct response. -9.79. What is the difference between the Female students (as % of total students) of Papua New Guinea in 1979 and the Female students (as % of total students) of Togo in 1998?
Make the answer very short. 2.92. What is the difference between the Female students (as % of total students) of Papua New Guinea in 1979 and the Female students (as % of total students) of Vietnam in 1998?
Your response must be concise. -15.5. What is the difference between the Female students (as % of total students) of Togo in 1979 and the Female students (as % of total students) of Vietnam in 1998?
Make the answer very short. -23.52. What is the difference between the Female students (as % of total students) of Middle East & North Africa (all income levels) in 1980 and the Female students (as % of total students) of Papua New Guinea in 1981?
Provide a succinct answer. 4.57. What is the difference between the Female students (as % of total students) in Middle East & North Africa (all income levels) in 1980 and the Female students (as % of total students) in Togo in 1981?
Make the answer very short. 13.45. What is the difference between the Female students (as % of total students) of Middle East & North Africa (all income levels) in 1980 and the Female students (as % of total students) of Vietnam in 1981?
Your answer should be compact. -9.52. What is the difference between the Female students (as % of total students) of Papua New Guinea in 1980 and the Female students (as % of total students) of Togo in 1981?
Keep it short and to the point. 8.34. What is the difference between the Female students (as % of total students) in Papua New Guinea in 1980 and the Female students (as % of total students) in Vietnam in 1981?
Offer a terse response. -14.63. What is the difference between the Female students (as % of total students) in Togo in 1980 and the Female students (as % of total students) in Vietnam in 1981?
Give a very brief answer. -23.18. What is the difference between the Female students (as % of total students) in Middle East & North Africa (all income levels) in 1980 and the Female students (as % of total students) in Papua New Guinea in 1986?
Keep it short and to the point. 0.83. What is the difference between the Female students (as % of total students) of Middle East & North Africa (all income levels) in 1980 and the Female students (as % of total students) of Togo in 1986?
Provide a short and direct response. 13.93. What is the difference between the Female students (as % of total students) in Middle East & North Africa (all income levels) in 1980 and the Female students (as % of total students) in Vietnam in 1986?
Give a very brief answer. -9.82. What is the difference between the Female students (as % of total students) in Papua New Guinea in 1980 and the Female students (as % of total students) in Togo in 1986?
Your answer should be very brief. 8.82. What is the difference between the Female students (as % of total students) in Papua New Guinea in 1980 and the Female students (as % of total students) in Vietnam in 1986?
Provide a short and direct response. -14.94. What is the difference between the Female students (as % of total students) in Togo in 1980 and the Female students (as % of total students) in Vietnam in 1986?
Your answer should be compact. -23.48. What is the difference between the Female students (as % of total students) in Middle East & North Africa (all income levels) in 1980 and the Female students (as % of total students) in Papua New Guinea in 1998?
Your answer should be very brief. -4.34. What is the difference between the Female students (as % of total students) of Middle East & North Africa (all income levels) in 1980 and the Female students (as % of total students) of Togo in 1998?
Keep it short and to the point. 8.97. What is the difference between the Female students (as % of total students) in Middle East & North Africa (all income levels) in 1980 and the Female students (as % of total students) in Vietnam in 1998?
Offer a terse response. -9.44. What is the difference between the Female students (as % of total students) in Papua New Guinea in 1980 and the Female students (as % of total students) in Togo in 1998?
Offer a terse response. 3.86. What is the difference between the Female students (as % of total students) in Papua New Guinea in 1980 and the Female students (as % of total students) in Vietnam in 1998?
Offer a terse response. -14.55. What is the difference between the Female students (as % of total students) of Togo in 1980 and the Female students (as % of total students) of Vietnam in 1998?
Ensure brevity in your answer.  -23.1. What is the difference between the Female students (as % of total students) of Middle East & North Africa (all income levels) in 1981 and the Female students (as % of total students) of Papua New Guinea in 1986?
Offer a very short reply. 1.51. What is the difference between the Female students (as % of total students) in Middle East & North Africa (all income levels) in 1981 and the Female students (as % of total students) in Togo in 1986?
Your response must be concise. 14.61. What is the difference between the Female students (as % of total students) in Middle East & North Africa (all income levels) in 1981 and the Female students (as % of total students) in Vietnam in 1986?
Your response must be concise. -9.15. What is the difference between the Female students (as % of total students) in Papua New Guinea in 1981 and the Female students (as % of total students) in Togo in 1986?
Provide a succinct answer. 9.36. What is the difference between the Female students (as % of total students) of Papua New Guinea in 1981 and the Female students (as % of total students) of Vietnam in 1986?
Make the answer very short. -14.39. What is the difference between the Female students (as % of total students) in Togo in 1981 and the Female students (as % of total students) in Vietnam in 1986?
Offer a terse response. -23.27. What is the difference between the Female students (as % of total students) in Middle East & North Africa (all income levels) in 1981 and the Female students (as % of total students) in Papua New Guinea in 1998?
Keep it short and to the point. -3.66. What is the difference between the Female students (as % of total students) in Middle East & North Africa (all income levels) in 1981 and the Female students (as % of total students) in Togo in 1998?
Offer a very short reply. 9.65. What is the difference between the Female students (as % of total students) in Middle East & North Africa (all income levels) in 1981 and the Female students (as % of total students) in Vietnam in 1998?
Your answer should be very brief. -8.77. What is the difference between the Female students (as % of total students) of Papua New Guinea in 1981 and the Female students (as % of total students) of Togo in 1998?
Your response must be concise. 4.4. What is the difference between the Female students (as % of total students) in Papua New Guinea in 1981 and the Female students (as % of total students) in Vietnam in 1998?
Keep it short and to the point. -14.01. What is the difference between the Female students (as % of total students) in Togo in 1981 and the Female students (as % of total students) in Vietnam in 1998?
Provide a short and direct response. -22.89. What is the difference between the Female students (as % of total students) of Middle East & North Africa (all income levels) in 1986 and the Female students (as % of total students) of Papua New Guinea in 1998?
Make the answer very short. -1.32. What is the difference between the Female students (as % of total students) of Middle East & North Africa (all income levels) in 1986 and the Female students (as % of total students) of Togo in 1998?
Keep it short and to the point. 11.99. What is the difference between the Female students (as % of total students) in Middle East & North Africa (all income levels) in 1986 and the Female students (as % of total students) in Vietnam in 1998?
Keep it short and to the point. -6.42. What is the difference between the Female students (as % of total students) of Papua New Guinea in 1986 and the Female students (as % of total students) of Togo in 1998?
Give a very brief answer. 8.14. What is the difference between the Female students (as % of total students) in Papua New Guinea in 1986 and the Female students (as % of total students) in Vietnam in 1998?
Provide a succinct answer. -10.28. What is the difference between the Female students (as % of total students) of Togo in 1986 and the Female students (as % of total students) of Vietnam in 1998?
Provide a succinct answer. -23.37. What is the average Female students (as % of total students) of Middle East & North Africa (all income levels) per year?
Make the answer very short. 38.51. What is the average Female students (as % of total students) of Papua New Guinea per year?
Your answer should be compact. 33.27. What is the average Female students (as % of total students) of Togo per year?
Give a very brief answer. 24.02. What is the average Female students (as % of total students) of Vietnam per year?
Offer a very short reply. 47.63. In the year 1976, what is the difference between the Female students (as % of total students) in Middle East & North Africa (all income levels) and Female students (as % of total students) in Papua New Guinea?
Provide a short and direct response. 5.02. In the year 1976, what is the difference between the Female students (as % of total students) in Middle East & North Africa (all income levels) and Female students (as % of total students) in Togo?
Your answer should be very brief. 12.35. In the year 1976, what is the difference between the Female students (as % of total students) of Middle East & North Africa (all income levels) and Female students (as % of total students) of Vietnam?
Provide a succinct answer. -14.56. In the year 1976, what is the difference between the Female students (as % of total students) of Papua New Guinea and Female students (as % of total students) of Togo?
Offer a terse response. 7.33. In the year 1976, what is the difference between the Female students (as % of total students) in Papua New Guinea and Female students (as % of total students) in Vietnam?
Provide a short and direct response. -19.58. In the year 1976, what is the difference between the Female students (as % of total students) in Togo and Female students (as % of total students) in Vietnam?
Make the answer very short. -26.91. In the year 1977, what is the difference between the Female students (as % of total students) in Middle East & North Africa (all income levels) and Female students (as % of total students) in Papua New Guinea?
Offer a very short reply. 6.08. In the year 1977, what is the difference between the Female students (as % of total students) in Middle East & North Africa (all income levels) and Female students (as % of total students) in Togo?
Your response must be concise. 13.39. In the year 1977, what is the difference between the Female students (as % of total students) in Middle East & North Africa (all income levels) and Female students (as % of total students) in Vietnam?
Ensure brevity in your answer.  -12.77. In the year 1977, what is the difference between the Female students (as % of total students) in Papua New Guinea and Female students (as % of total students) in Togo?
Offer a terse response. 7.31. In the year 1977, what is the difference between the Female students (as % of total students) of Papua New Guinea and Female students (as % of total students) of Vietnam?
Provide a short and direct response. -18.85. In the year 1977, what is the difference between the Female students (as % of total students) of Togo and Female students (as % of total students) of Vietnam?
Make the answer very short. -26.16. In the year 1978, what is the difference between the Female students (as % of total students) in Middle East & North Africa (all income levels) and Female students (as % of total students) in Papua New Guinea?
Keep it short and to the point. 6.31. In the year 1978, what is the difference between the Female students (as % of total students) of Middle East & North Africa (all income levels) and Female students (as % of total students) of Togo?
Ensure brevity in your answer.  13.83. In the year 1978, what is the difference between the Female students (as % of total students) of Middle East & North Africa (all income levels) and Female students (as % of total students) of Vietnam?
Your answer should be compact. -8.72. In the year 1978, what is the difference between the Female students (as % of total students) in Papua New Guinea and Female students (as % of total students) in Togo?
Give a very brief answer. 7.52. In the year 1978, what is the difference between the Female students (as % of total students) of Papua New Guinea and Female students (as % of total students) of Vietnam?
Keep it short and to the point. -15.03. In the year 1978, what is the difference between the Female students (as % of total students) of Togo and Female students (as % of total students) of Vietnam?
Your response must be concise. -22.55. In the year 1979, what is the difference between the Female students (as % of total students) of Middle East & North Africa (all income levels) and Female students (as % of total students) of Papua New Guinea?
Provide a succinct answer. 5.71. In the year 1979, what is the difference between the Female students (as % of total students) of Middle East & North Africa (all income levels) and Female students (as % of total students) of Togo?
Make the answer very short. 13.73. In the year 1979, what is the difference between the Female students (as % of total students) of Middle East & North Africa (all income levels) and Female students (as % of total students) of Vietnam?
Provide a short and direct response. -11.09. In the year 1979, what is the difference between the Female students (as % of total students) in Papua New Guinea and Female students (as % of total students) in Togo?
Make the answer very short. 8.02. In the year 1979, what is the difference between the Female students (as % of total students) of Papua New Guinea and Female students (as % of total students) of Vietnam?
Provide a succinct answer. -16.8. In the year 1979, what is the difference between the Female students (as % of total students) in Togo and Female students (as % of total students) in Vietnam?
Provide a short and direct response. -24.82. In the year 1980, what is the difference between the Female students (as % of total students) of Middle East & North Africa (all income levels) and Female students (as % of total students) of Papua New Guinea?
Ensure brevity in your answer.  5.11. In the year 1980, what is the difference between the Female students (as % of total students) in Middle East & North Africa (all income levels) and Female students (as % of total students) in Togo?
Your answer should be very brief. 13.66. In the year 1980, what is the difference between the Female students (as % of total students) of Middle East & North Africa (all income levels) and Female students (as % of total students) of Vietnam?
Offer a terse response. -9.62. In the year 1980, what is the difference between the Female students (as % of total students) of Papua New Guinea and Female students (as % of total students) of Togo?
Provide a short and direct response. 8.55. In the year 1980, what is the difference between the Female students (as % of total students) of Papua New Guinea and Female students (as % of total students) of Vietnam?
Offer a terse response. -14.74. In the year 1980, what is the difference between the Female students (as % of total students) in Togo and Female students (as % of total students) in Vietnam?
Offer a very short reply. -23.28. In the year 1981, what is the difference between the Female students (as % of total students) of Middle East & North Africa (all income levels) and Female students (as % of total students) of Papua New Guinea?
Keep it short and to the point. 5.25. In the year 1981, what is the difference between the Female students (as % of total students) in Middle East & North Africa (all income levels) and Female students (as % of total students) in Togo?
Your response must be concise. 14.12. In the year 1981, what is the difference between the Female students (as % of total students) of Middle East & North Africa (all income levels) and Female students (as % of total students) of Vietnam?
Offer a terse response. -8.85. In the year 1981, what is the difference between the Female students (as % of total students) in Papua New Guinea and Female students (as % of total students) in Togo?
Offer a terse response. 8.88. In the year 1981, what is the difference between the Female students (as % of total students) of Papua New Guinea and Female students (as % of total students) of Vietnam?
Offer a very short reply. -14.09. In the year 1981, what is the difference between the Female students (as % of total students) in Togo and Female students (as % of total students) in Vietnam?
Ensure brevity in your answer.  -22.97. In the year 1986, what is the difference between the Female students (as % of total students) of Middle East & North Africa (all income levels) and Female students (as % of total students) of Papua New Guinea?
Your answer should be compact. 3.85. In the year 1986, what is the difference between the Female students (as % of total students) of Middle East & North Africa (all income levels) and Female students (as % of total students) of Togo?
Your answer should be very brief. 16.95. In the year 1986, what is the difference between the Female students (as % of total students) in Middle East & North Africa (all income levels) and Female students (as % of total students) in Vietnam?
Your answer should be compact. -6.81. In the year 1986, what is the difference between the Female students (as % of total students) of Papua New Guinea and Female students (as % of total students) of Togo?
Offer a terse response. 13.1. In the year 1986, what is the difference between the Female students (as % of total students) in Papua New Guinea and Female students (as % of total students) in Vietnam?
Provide a short and direct response. -10.66. In the year 1986, what is the difference between the Female students (as % of total students) of Togo and Female students (as % of total students) of Vietnam?
Your response must be concise. -23.76. In the year 1998, what is the difference between the Female students (as % of total students) of Middle East & North Africa (all income levels) and Female students (as % of total students) of Papua New Guinea?
Your response must be concise. 4.52. In the year 1998, what is the difference between the Female students (as % of total students) of Middle East & North Africa (all income levels) and Female students (as % of total students) of Togo?
Your answer should be compact. 17.83. In the year 1998, what is the difference between the Female students (as % of total students) in Middle East & North Africa (all income levels) and Female students (as % of total students) in Vietnam?
Your answer should be very brief. -0.58. In the year 1998, what is the difference between the Female students (as % of total students) of Papua New Guinea and Female students (as % of total students) of Togo?
Your answer should be compact. 13.31. In the year 1998, what is the difference between the Female students (as % of total students) of Papua New Guinea and Female students (as % of total students) of Vietnam?
Your response must be concise. -5.11. In the year 1998, what is the difference between the Female students (as % of total students) in Togo and Female students (as % of total students) in Vietnam?
Offer a terse response. -18.41. What is the ratio of the Female students (as % of total students) in Middle East & North Africa (all income levels) in 1976 to that in 1977?
Your response must be concise. 0.98. What is the ratio of the Female students (as % of total students) of Papua New Guinea in 1976 to that in 1977?
Keep it short and to the point. 1.02. What is the ratio of the Female students (as % of total students) in Togo in 1976 to that in 1977?
Your answer should be compact. 1.02. What is the ratio of the Female students (as % of total students) of Vietnam in 1976 to that in 1977?
Give a very brief answer. 1.02. What is the ratio of the Female students (as % of total students) in Middle East & North Africa (all income levels) in 1976 to that in 1978?
Give a very brief answer. 0.97. What is the ratio of the Female students (as % of total students) in Papua New Guinea in 1976 to that in 1978?
Give a very brief answer. 1.01. What is the ratio of the Female students (as % of total students) of Togo in 1976 to that in 1978?
Keep it short and to the point. 1.02. What is the ratio of the Female students (as % of total students) in Vietnam in 1976 to that in 1978?
Offer a very short reply. 1.11. What is the ratio of the Female students (as % of total students) of Middle East & North Africa (all income levels) in 1976 to that in 1979?
Your response must be concise. 0.96. What is the ratio of the Female students (as % of total students) of Papua New Guinea in 1976 to that in 1979?
Your answer should be compact. 0.97. What is the ratio of the Female students (as % of total students) in Vietnam in 1976 to that in 1979?
Your answer should be compact. 1.04. What is the ratio of the Female students (as % of total students) in Middle East & North Africa (all income levels) in 1976 to that in 1980?
Your response must be concise. 0.95. What is the ratio of the Female students (as % of total students) in Papua New Guinea in 1976 to that in 1980?
Your answer should be compact. 0.94. What is the ratio of the Female students (as % of total students) in Togo in 1976 to that in 1980?
Make the answer very short. 0.98. What is the ratio of the Female students (as % of total students) of Vietnam in 1976 to that in 1980?
Your answer should be very brief. 1.07. What is the ratio of the Female students (as % of total students) in Middle East & North Africa (all income levels) in 1976 to that in 1981?
Your answer should be compact. 0.93. What is the ratio of the Female students (as % of total students) in Papua New Guinea in 1976 to that in 1981?
Provide a succinct answer. 0.93. What is the ratio of the Female students (as % of total students) of Togo in 1976 to that in 1981?
Make the answer very short. 0.97. What is the ratio of the Female students (as % of total students) of Vietnam in 1976 to that in 1981?
Give a very brief answer. 1.07. What is the ratio of the Female students (as % of total students) in Middle East & North Africa (all income levels) in 1976 to that in 1986?
Your answer should be very brief. 0.88. What is the ratio of the Female students (as % of total students) in Papua New Guinea in 1976 to that in 1986?
Give a very brief answer. 0.83. What is the ratio of the Female students (as % of total students) in Vietnam in 1976 to that in 1986?
Provide a short and direct response. 1.06. What is the ratio of the Female students (as % of total students) of Middle East & North Africa (all income levels) in 1976 to that in 1998?
Offer a terse response. 0.77. What is the ratio of the Female students (as % of total students) of Papua New Guinea in 1976 to that in 1998?
Your response must be concise. 0.73. What is the ratio of the Female students (as % of total students) of Togo in 1976 to that in 1998?
Ensure brevity in your answer.  0.82. What is the ratio of the Female students (as % of total students) of Vietnam in 1976 to that in 1998?
Your answer should be compact. 1.07. What is the ratio of the Female students (as % of total students) of Middle East & North Africa (all income levels) in 1977 to that in 1978?
Your answer should be very brief. 0.99. What is the ratio of the Female students (as % of total students) in Togo in 1977 to that in 1978?
Ensure brevity in your answer.  1. What is the ratio of the Female students (as % of total students) in Vietnam in 1977 to that in 1978?
Ensure brevity in your answer.  1.08. What is the ratio of the Female students (as % of total students) of Middle East & North Africa (all income levels) in 1977 to that in 1979?
Your answer should be compact. 0.97. What is the ratio of the Female students (as % of total students) of Papua New Guinea in 1977 to that in 1979?
Your response must be concise. 0.96. What is the ratio of the Female students (as % of total students) in Togo in 1977 to that in 1979?
Provide a succinct answer. 0.97. What is the ratio of the Female students (as % of total students) of Vietnam in 1977 to that in 1979?
Offer a terse response. 1.02. What is the ratio of the Female students (as % of total students) in Middle East & North Africa (all income levels) in 1977 to that in 1980?
Ensure brevity in your answer.  0.97. What is the ratio of the Female students (as % of total students) in Papua New Guinea in 1977 to that in 1980?
Give a very brief answer. 0.93. What is the ratio of the Female students (as % of total students) of Togo in 1977 to that in 1980?
Give a very brief answer. 0.96. What is the ratio of the Female students (as % of total students) of Vietnam in 1977 to that in 1980?
Keep it short and to the point. 1.04. What is the ratio of the Female students (as % of total students) in Middle East & North Africa (all income levels) in 1977 to that in 1981?
Your answer should be compact. 0.95. What is the ratio of the Female students (as % of total students) of Papua New Guinea in 1977 to that in 1981?
Ensure brevity in your answer.  0.92. What is the ratio of the Female students (as % of total students) in Togo in 1977 to that in 1981?
Your answer should be very brief. 0.95. What is the ratio of the Female students (as % of total students) in Vietnam in 1977 to that in 1981?
Keep it short and to the point. 1.04. What is the ratio of the Female students (as % of total students) in Middle East & North Africa (all income levels) in 1977 to that in 1986?
Give a very brief answer. 0.89. What is the ratio of the Female students (as % of total students) of Papua New Guinea in 1977 to that in 1986?
Make the answer very short. 0.82. What is the ratio of the Female students (as % of total students) of Togo in 1977 to that in 1986?
Your answer should be compact. 0.97. What is the ratio of the Female students (as % of total students) of Vietnam in 1977 to that in 1986?
Provide a succinct answer. 1.04. What is the ratio of the Female students (as % of total students) in Middle East & North Africa (all income levels) in 1977 to that in 1998?
Provide a short and direct response. 0.78. What is the ratio of the Female students (as % of total students) in Papua New Guinea in 1977 to that in 1998?
Ensure brevity in your answer.  0.72. What is the ratio of the Female students (as % of total students) of Togo in 1977 to that in 1998?
Provide a short and direct response. 0.8. What is the ratio of the Female students (as % of total students) of Vietnam in 1977 to that in 1998?
Provide a succinct answer. 1.04. What is the ratio of the Female students (as % of total students) in Papua New Guinea in 1978 to that in 1979?
Ensure brevity in your answer.  0.97. What is the ratio of the Female students (as % of total students) of Togo in 1978 to that in 1979?
Provide a succinct answer. 0.97. What is the ratio of the Female students (as % of total students) of Vietnam in 1978 to that in 1979?
Keep it short and to the point. 0.94. What is the ratio of the Female students (as % of total students) in Middle East & North Africa (all income levels) in 1978 to that in 1980?
Make the answer very short. 0.98. What is the ratio of the Female students (as % of total students) of Papua New Guinea in 1978 to that in 1980?
Keep it short and to the point. 0.94. What is the ratio of the Female students (as % of total students) in Togo in 1978 to that in 1980?
Ensure brevity in your answer.  0.96. What is the ratio of the Female students (as % of total students) in Vietnam in 1978 to that in 1980?
Your response must be concise. 0.96. What is the ratio of the Female students (as % of total students) of Middle East & North Africa (all income levels) in 1978 to that in 1981?
Offer a terse response. 0.96. What is the ratio of the Female students (as % of total students) in Papua New Guinea in 1978 to that in 1981?
Offer a very short reply. 0.92. What is the ratio of the Female students (as % of total students) of Togo in 1978 to that in 1981?
Offer a terse response. 0.95. What is the ratio of the Female students (as % of total students) in Vietnam in 1978 to that in 1981?
Offer a terse response. 0.97. What is the ratio of the Female students (as % of total students) of Middle East & North Africa (all income levels) in 1978 to that in 1986?
Your answer should be very brief. 0.9. What is the ratio of the Female students (as % of total students) of Papua New Guinea in 1978 to that in 1986?
Offer a terse response. 0.83. What is the ratio of the Female students (as % of total students) in Togo in 1978 to that in 1986?
Ensure brevity in your answer.  0.97. What is the ratio of the Female students (as % of total students) of Vietnam in 1978 to that in 1986?
Make the answer very short. 0.96. What is the ratio of the Female students (as % of total students) in Middle East & North Africa (all income levels) in 1978 to that in 1998?
Your response must be concise. 0.79. What is the ratio of the Female students (as % of total students) of Papua New Guinea in 1978 to that in 1998?
Ensure brevity in your answer.  0.73. What is the ratio of the Female students (as % of total students) of Togo in 1978 to that in 1998?
Give a very brief answer. 0.8. What is the ratio of the Female students (as % of total students) of Vietnam in 1978 to that in 1998?
Your response must be concise. 0.97. What is the ratio of the Female students (as % of total students) of Middle East & North Africa (all income levels) in 1979 to that in 1980?
Your response must be concise. 0.99. What is the ratio of the Female students (as % of total students) in Papua New Guinea in 1979 to that in 1980?
Your answer should be very brief. 0.97. What is the ratio of the Female students (as % of total students) of Togo in 1979 to that in 1980?
Make the answer very short. 0.98. What is the ratio of the Female students (as % of total students) of Vietnam in 1979 to that in 1980?
Your answer should be compact. 1.02. What is the ratio of the Female students (as % of total students) in Middle East & North Africa (all income levels) in 1979 to that in 1981?
Make the answer very short. 0.97. What is the ratio of the Female students (as % of total students) of Papua New Guinea in 1979 to that in 1981?
Offer a very short reply. 0.95. What is the ratio of the Female students (as % of total students) of Togo in 1979 to that in 1981?
Provide a short and direct response. 0.97. What is the ratio of the Female students (as % of total students) in Middle East & North Africa (all income levels) in 1979 to that in 1986?
Ensure brevity in your answer.  0.92. What is the ratio of the Female students (as % of total students) of Papua New Guinea in 1979 to that in 1986?
Your answer should be compact. 0.86. What is the ratio of the Female students (as % of total students) of Vietnam in 1979 to that in 1986?
Give a very brief answer. 1.02. What is the ratio of the Female students (as % of total students) in Middle East & North Africa (all income levels) in 1979 to that in 1998?
Make the answer very short. 0.8. What is the ratio of the Female students (as % of total students) of Papua New Guinea in 1979 to that in 1998?
Provide a succinct answer. 0.75. What is the ratio of the Female students (as % of total students) of Togo in 1979 to that in 1998?
Ensure brevity in your answer.  0.82. What is the ratio of the Female students (as % of total students) of Vietnam in 1979 to that in 1998?
Provide a short and direct response. 1.03. What is the ratio of the Female students (as % of total students) of Middle East & North Africa (all income levels) in 1980 to that in 1981?
Your answer should be very brief. 0.98. What is the ratio of the Female students (as % of total students) of Papua New Guinea in 1980 to that in 1981?
Ensure brevity in your answer.  0.98. What is the ratio of the Female students (as % of total students) in Vietnam in 1980 to that in 1981?
Offer a very short reply. 1. What is the ratio of the Female students (as % of total students) in Middle East & North Africa (all income levels) in 1980 to that in 1986?
Ensure brevity in your answer.  0.93. What is the ratio of the Female students (as % of total students) in Papua New Guinea in 1980 to that in 1986?
Offer a terse response. 0.88. What is the ratio of the Female students (as % of total students) in Togo in 1980 to that in 1986?
Your response must be concise. 1.01. What is the ratio of the Female students (as % of total students) of Middle East & North Africa (all income levels) in 1980 to that in 1998?
Your answer should be compact. 0.81. What is the ratio of the Female students (as % of total students) in Papua New Guinea in 1980 to that in 1998?
Ensure brevity in your answer.  0.77. What is the ratio of the Female students (as % of total students) of Togo in 1980 to that in 1998?
Provide a succinct answer. 0.84. What is the ratio of the Female students (as % of total students) in Vietnam in 1980 to that in 1998?
Provide a short and direct response. 1. What is the ratio of the Female students (as % of total students) of Middle East & North Africa (all income levels) in 1981 to that in 1986?
Your answer should be very brief. 0.94. What is the ratio of the Female students (as % of total students) in Papua New Guinea in 1981 to that in 1986?
Your answer should be very brief. 0.9. What is the ratio of the Female students (as % of total students) in Togo in 1981 to that in 1986?
Your answer should be compact. 1.02. What is the ratio of the Female students (as % of total students) in Vietnam in 1981 to that in 1986?
Keep it short and to the point. 0.99. What is the ratio of the Female students (as % of total students) of Middle East & North Africa (all income levels) in 1981 to that in 1998?
Your response must be concise. 0.82. What is the ratio of the Female students (as % of total students) in Papua New Guinea in 1981 to that in 1998?
Your answer should be very brief. 0.79. What is the ratio of the Female students (as % of total students) of Togo in 1981 to that in 1998?
Give a very brief answer. 0.84. What is the ratio of the Female students (as % of total students) of Vietnam in 1981 to that in 1998?
Your response must be concise. 1. What is the ratio of the Female students (as % of total students) of Middle East & North Africa (all income levels) in 1986 to that in 1998?
Make the answer very short. 0.87. What is the ratio of the Female students (as % of total students) of Papua New Guinea in 1986 to that in 1998?
Make the answer very short. 0.88. What is the ratio of the Female students (as % of total students) of Togo in 1986 to that in 1998?
Offer a very short reply. 0.83. What is the ratio of the Female students (as % of total students) in Vietnam in 1986 to that in 1998?
Offer a very short reply. 1.01. What is the difference between the highest and the second highest Female students (as % of total students) of Middle East & North Africa (all income levels)?
Your answer should be compact. 5.84. What is the difference between the highest and the second highest Female students (as % of total students) in Papua New Guinea?
Your answer should be very brief. 5.17. What is the difference between the highest and the second highest Female students (as % of total students) in Togo?
Provide a short and direct response. 4.48. What is the difference between the highest and the second highest Female students (as % of total students) in Vietnam?
Offer a very short reply. 1.2. What is the difference between the highest and the lowest Female students (as % of total students) of Middle East & North Africa (all income levels)?
Your answer should be very brief. 10.73. What is the difference between the highest and the lowest Female students (as % of total students) of Papua New Guinea?
Your answer should be compact. 11.7. What is the difference between the highest and the lowest Female students (as % of total students) in Togo?
Your answer should be very brief. 5.7. What is the difference between the highest and the lowest Female students (as % of total students) of Vietnam?
Your answer should be compact. 4.81. 